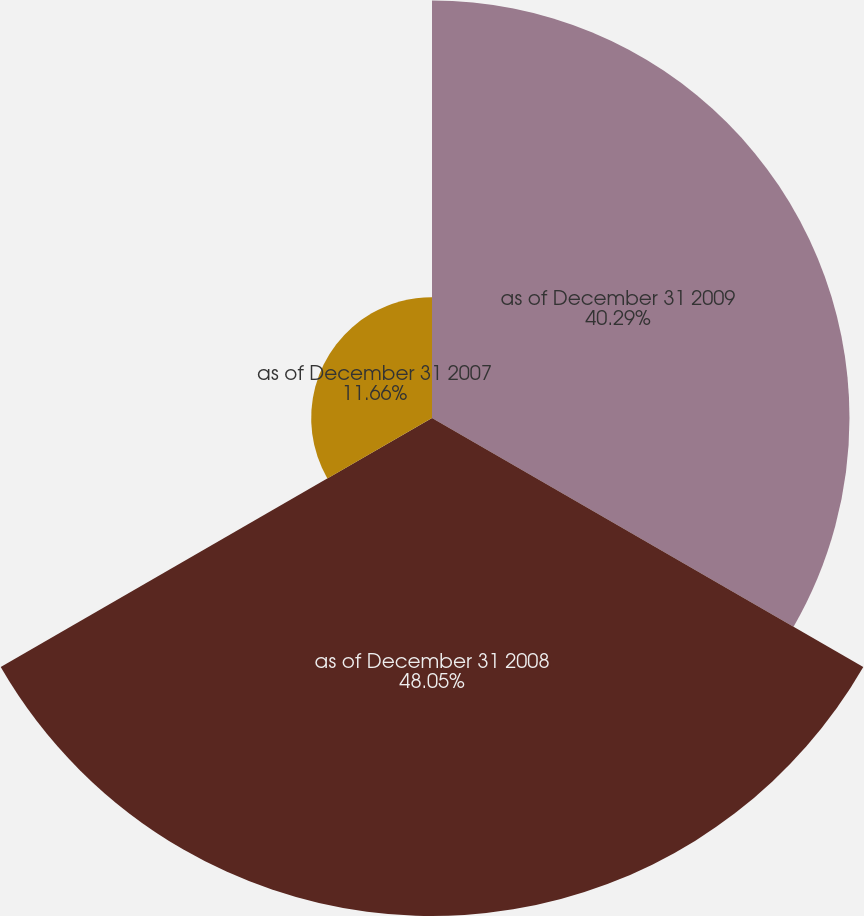Convert chart. <chart><loc_0><loc_0><loc_500><loc_500><pie_chart><fcel>as of December 31 2009<fcel>as of December 31 2008<fcel>as of December 31 2007<nl><fcel>40.29%<fcel>48.06%<fcel>11.66%<nl></chart> 